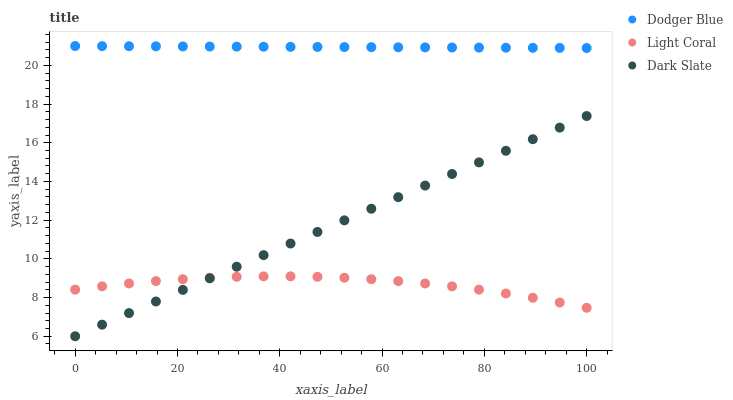Does Light Coral have the minimum area under the curve?
Answer yes or no. Yes. Does Dodger Blue have the maximum area under the curve?
Answer yes or no. Yes. Does Dark Slate have the minimum area under the curve?
Answer yes or no. No. Does Dark Slate have the maximum area under the curve?
Answer yes or no. No. Is Dark Slate the smoothest?
Answer yes or no. Yes. Is Light Coral the roughest?
Answer yes or no. Yes. Is Dodger Blue the smoothest?
Answer yes or no. No. Is Dodger Blue the roughest?
Answer yes or no. No. Does Dark Slate have the lowest value?
Answer yes or no. Yes. Does Dodger Blue have the lowest value?
Answer yes or no. No. Does Dodger Blue have the highest value?
Answer yes or no. Yes. Does Dark Slate have the highest value?
Answer yes or no. No. Is Light Coral less than Dodger Blue?
Answer yes or no. Yes. Is Dodger Blue greater than Light Coral?
Answer yes or no. Yes. Does Dark Slate intersect Light Coral?
Answer yes or no. Yes. Is Dark Slate less than Light Coral?
Answer yes or no. No. Is Dark Slate greater than Light Coral?
Answer yes or no. No. Does Light Coral intersect Dodger Blue?
Answer yes or no. No. 